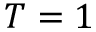Convert formula to latex. <formula><loc_0><loc_0><loc_500><loc_500>T = 1</formula> 